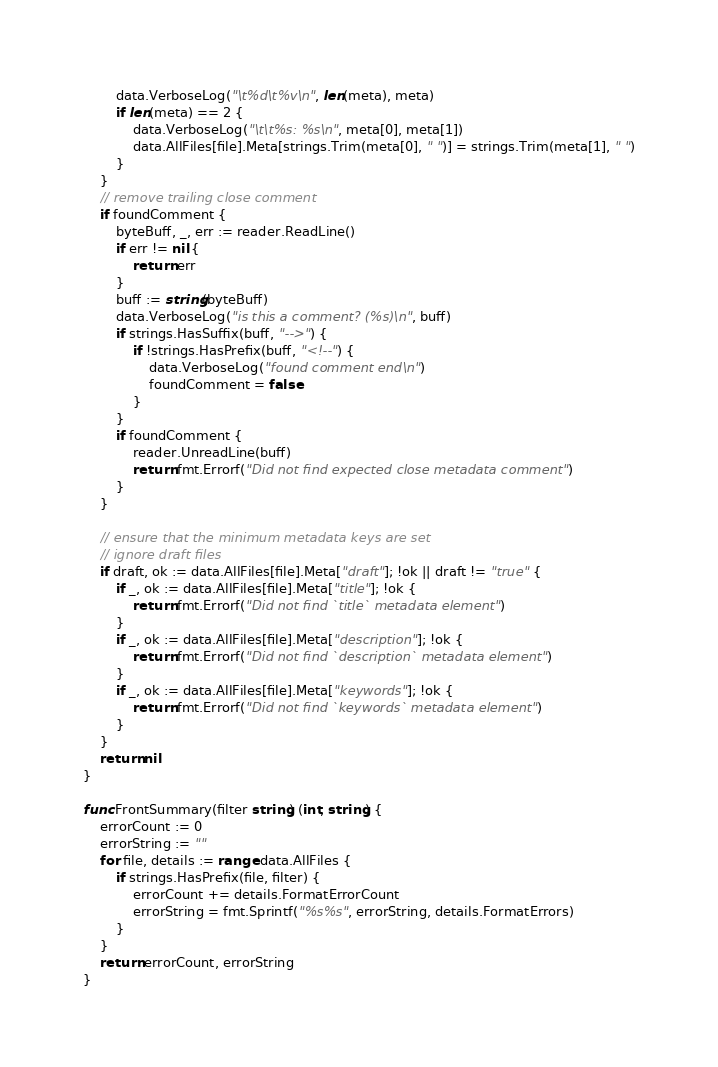Convert code to text. <code><loc_0><loc_0><loc_500><loc_500><_Go_>		data.VerboseLog("\t%d\t%v\n", len(meta), meta)
		if len(meta) == 2 {
			data.VerboseLog("\t\t%s: %s\n", meta[0], meta[1])
			data.AllFiles[file].Meta[strings.Trim(meta[0], " ")] = strings.Trim(meta[1], " ")
		}
	}
	// remove trailing close comment
	if foundComment {
		byteBuff, _, err := reader.ReadLine()
		if err != nil {
			return err
		}
		buff := string(byteBuff)
		data.VerboseLog("is this a comment? (%s)\n", buff)
		if strings.HasSuffix(buff, "-->") {
			if !strings.HasPrefix(buff, "<!--") {
				data.VerboseLog("found comment end\n")
				foundComment = false
			}
		}
		if foundComment {
			reader.UnreadLine(buff)
			return fmt.Errorf("Did not find expected close metadata comment")
		}
	}

	// ensure that the minimum metadata keys are set
	// ignore draft files
	if draft, ok := data.AllFiles[file].Meta["draft"]; !ok || draft != "true" {
		if _, ok := data.AllFiles[file].Meta["title"]; !ok {
			return fmt.Errorf("Did not find `title` metadata element")
		}
		if _, ok := data.AllFiles[file].Meta["description"]; !ok {
			return fmt.Errorf("Did not find `description` metadata element")
		}
		if _, ok := data.AllFiles[file].Meta["keywords"]; !ok {
			return fmt.Errorf("Did not find `keywords` metadata element")
		}
	}
	return nil
}

func FrontSummary(filter string) (int, string) {
	errorCount := 0
	errorString := ""
	for file, details := range data.AllFiles {
		if strings.HasPrefix(file, filter) {
			errorCount += details.FormatErrorCount
			errorString = fmt.Sprintf("%s%s", errorString, details.FormatErrors)
		}
	}
	return errorCount, errorString
}
</code> 